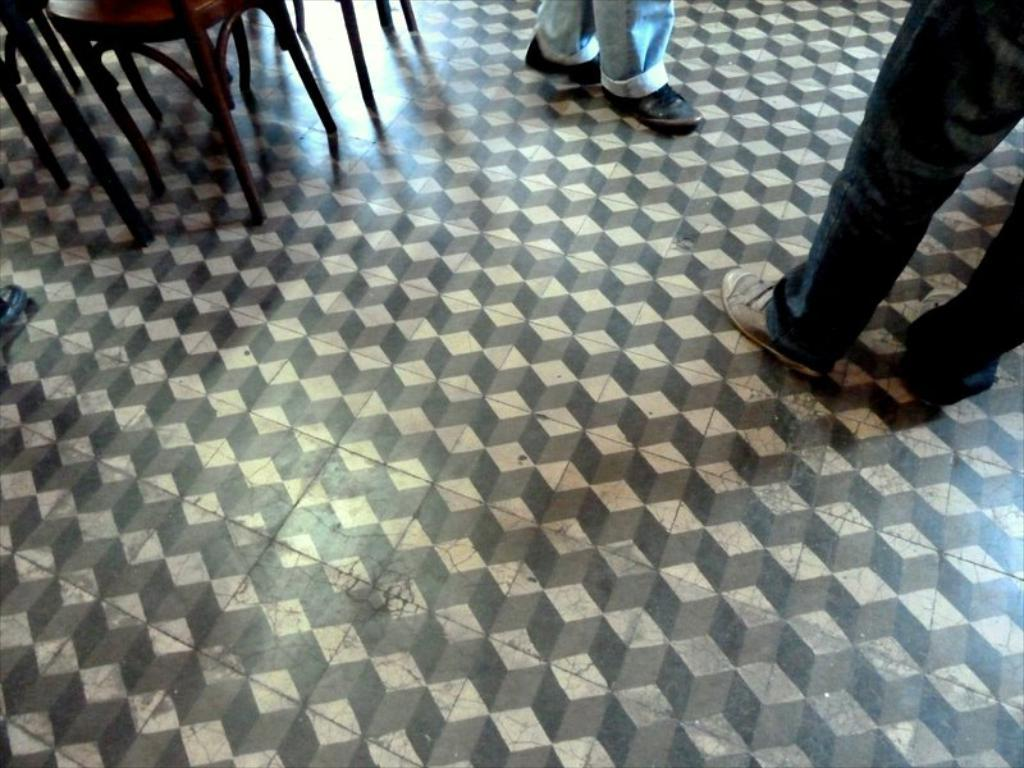What can be seen in the image that belongs to people? There are legs of two people in the image. What objects are present in the image that people might sit on? There are chairs in the image. What color is the spark that is present in the image? There is no spark present in the image. How does the paint on the chairs in the image express anger? There is no paint or expression of anger in the image; it only shows chairs and legs of two people. 